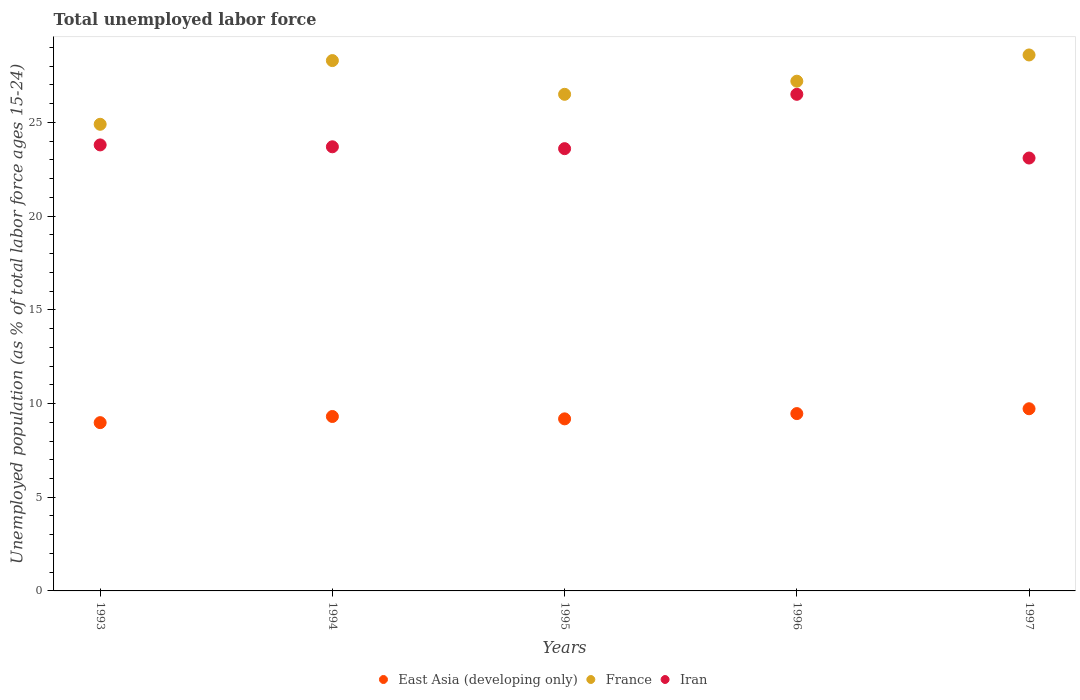How many different coloured dotlines are there?
Your response must be concise. 3. Is the number of dotlines equal to the number of legend labels?
Make the answer very short. Yes. What is the percentage of unemployed population in in East Asia (developing only) in 1996?
Give a very brief answer. 9.46. Across all years, what is the maximum percentage of unemployed population in in France?
Provide a short and direct response. 28.6. Across all years, what is the minimum percentage of unemployed population in in East Asia (developing only)?
Offer a very short reply. 8.98. In which year was the percentage of unemployed population in in France maximum?
Provide a short and direct response. 1997. In which year was the percentage of unemployed population in in Iran minimum?
Give a very brief answer. 1997. What is the total percentage of unemployed population in in East Asia (developing only) in the graph?
Offer a very short reply. 46.65. What is the difference between the percentage of unemployed population in in East Asia (developing only) in 1994 and that in 1996?
Keep it short and to the point. -0.15. What is the difference between the percentage of unemployed population in in France in 1997 and the percentage of unemployed population in in East Asia (developing only) in 1996?
Provide a succinct answer. 19.14. What is the average percentage of unemployed population in in France per year?
Provide a short and direct response. 27.1. In the year 1993, what is the difference between the percentage of unemployed population in in Iran and percentage of unemployed population in in East Asia (developing only)?
Make the answer very short. 14.82. In how many years, is the percentage of unemployed population in in Iran greater than 1 %?
Give a very brief answer. 5. What is the ratio of the percentage of unemployed population in in East Asia (developing only) in 1995 to that in 1996?
Provide a short and direct response. 0.97. Is the percentage of unemployed population in in East Asia (developing only) in 1994 less than that in 1995?
Ensure brevity in your answer.  No. Is the difference between the percentage of unemployed population in in Iran in 1995 and 1997 greater than the difference between the percentage of unemployed population in in East Asia (developing only) in 1995 and 1997?
Give a very brief answer. Yes. What is the difference between the highest and the second highest percentage of unemployed population in in East Asia (developing only)?
Provide a succinct answer. 0.26. What is the difference between the highest and the lowest percentage of unemployed population in in East Asia (developing only)?
Keep it short and to the point. 0.74. In how many years, is the percentage of unemployed population in in East Asia (developing only) greater than the average percentage of unemployed population in in East Asia (developing only) taken over all years?
Make the answer very short. 2. Is the sum of the percentage of unemployed population in in East Asia (developing only) in 1995 and 1996 greater than the maximum percentage of unemployed population in in Iran across all years?
Your answer should be very brief. No. Is it the case that in every year, the sum of the percentage of unemployed population in in East Asia (developing only) and percentage of unemployed population in in France  is greater than the percentage of unemployed population in in Iran?
Your answer should be very brief. Yes. Does the percentage of unemployed population in in Iran monotonically increase over the years?
Your response must be concise. No. Is the percentage of unemployed population in in France strictly greater than the percentage of unemployed population in in Iran over the years?
Your response must be concise. Yes. How many dotlines are there?
Give a very brief answer. 3. How many years are there in the graph?
Keep it short and to the point. 5. Are the values on the major ticks of Y-axis written in scientific E-notation?
Your answer should be compact. No. Where does the legend appear in the graph?
Your answer should be compact. Bottom center. How are the legend labels stacked?
Provide a succinct answer. Horizontal. What is the title of the graph?
Your answer should be compact. Total unemployed labor force. What is the label or title of the X-axis?
Keep it short and to the point. Years. What is the label or title of the Y-axis?
Your answer should be compact. Unemployed population (as % of total labor force ages 15-24). What is the Unemployed population (as % of total labor force ages 15-24) in East Asia (developing only) in 1993?
Ensure brevity in your answer.  8.98. What is the Unemployed population (as % of total labor force ages 15-24) in France in 1993?
Give a very brief answer. 24.9. What is the Unemployed population (as % of total labor force ages 15-24) in Iran in 1993?
Offer a terse response. 23.8. What is the Unemployed population (as % of total labor force ages 15-24) of East Asia (developing only) in 1994?
Provide a succinct answer. 9.31. What is the Unemployed population (as % of total labor force ages 15-24) of France in 1994?
Ensure brevity in your answer.  28.3. What is the Unemployed population (as % of total labor force ages 15-24) in Iran in 1994?
Keep it short and to the point. 23.7. What is the Unemployed population (as % of total labor force ages 15-24) in East Asia (developing only) in 1995?
Your response must be concise. 9.18. What is the Unemployed population (as % of total labor force ages 15-24) in Iran in 1995?
Provide a succinct answer. 23.6. What is the Unemployed population (as % of total labor force ages 15-24) of East Asia (developing only) in 1996?
Provide a succinct answer. 9.46. What is the Unemployed population (as % of total labor force ages 15-24) in France in 1996?
Your answer should be very brief. 27.2. What is the Unemployed population (as % of total labor force ages 15-24) of Iran in 1996?
Make the answer very short. 26.5. What is the Unemployed population (as % of total labor force ages 15-24) in East Asia (developing only) in 1997?
Offer a very short reply. 9.72. What is the Unemployed population (as % of total labor force ages 15-24) of France in 1997?
Offer a terse response. 28.6. What is the Unemployed population (as % of total labor force ages 15-24) of Iran in 1997?
Keep it short and to the point. 23.1. Across all years, what is the maximum Unemployed population (as % of total labor force ages 15-24) in East Asia (developing only)?
Offer a very short reply. 9.72. Across all years, what is the maximum Unemployed population (as % of total labor force ages 15-24) of France?
Keep it short and to the point. 28.6. Across all years, what is the maximum Unemployed population (as % of total labor force ages 15-24) of Iran?
Provide a short and direct response. 26.5. Across all years, what is the minimum Unemployed population (as % of total labor force ages 15-24) in East Asia (developing only)?
Your answer should be compact. 8.98. Across all years, what is the minimum Unemployed population (as % of total labor force ages 15-24) of France?
Offer a very short reply. 24.9. Across all years, what is the minimum Unemployed population (as % of total labor force ages 15-24) of Iran?
Ensure brevity in your answer.  23.1. What is the total Unemployed population (as % of total labor force ages 15-24) of East Asia (developing only) in the graph?
Make the answer very short. 46.65. What is the total Unemployed population (as % of total labor force ages 15-24) in France in the graph?
Provide a succinct answer. 135.5. What is the total Unemployed population (as % of total labor force ages 15-24) in Iran in the graph?
Give a very brief answer. 120.7. What is the difference between the Unemployed population (as % of total labor force ages 15-24) of East Asia (developing only) in 1993 and that in 1994?
Your answer should be very brief. -0.33. What is the difference between the Unemployed population (as % of total labor force ages 15-24) in Iran in 1993 and that in 1994?
Make the answer very short. 0.1. What is the difference between the Unemployed population (as % of total labor force ages 15-24) in East Asia (developing only) in 1993 and that in 1995?
Keep it short and to the point. -0.2. What is the difference between the Unemployed population (as % of total labor force ages 15-24) in France in 1993 and that in 1995?
Offer a terse response. -1.6. What is the difference between the Unemployed population (as % of total labor force ages 15-24) of East Asia (developing only) in 1993 and that in 1996?
Provide a short and direct response. -0.48. What is the difference between the Unemployed population (as % of total labor force ages 15-24) in East Asia (developing only) in 1993 and that in 1997?
Your answer should be compact. -0.74. What is the difference between the Unemployed population (as % of total labor force ages 15-24) of France in 1993 and that in 1997?
Ensure brevity in your answer.  -3.7. What is the difference between the Unemployed population (as % of total labor force ages 15-24) in Iran in 1993 and that in 1997?
Ensure brevity in your answer.  0.7. What is the difference between the Unemployed population (as % of total labor force ages 15-24) in East Asia (developing only) in 1994 and that in 1995?
Ensure brevity in your answer.  0.13. What is the difference between the Unemployed population (as % of total labor force ages 15-24) in France in 1994 and that in 1995?
Your answer should be very brief. 1.8. What is the difference between the Unemployed population (as % of total labor force ages 15-24) of Iran in 1994 and that in 1995?
Keep it short and to the point. 0.1. What is the difference between the Unemployed population (as % of total labor force ages 15-24) in East Asia (developing only) in 1994 and that in 1996?
Your answer should be compact. -0.15. What is the difference between the Unemployed population (as % of total labor force ages 15-24) of France in 1994 and that in 1996?
Keep it short and to the point. 1.1. What is the difference between the Unemployed population (as % of total labor force ages 15-24) in East Asia (developing only) in 1994 and that in 1997?
Offer a terse response. -0.41. What is the difference between the Unemployed population (as % of total labor force ages 15-24) of East Asia (developing only) in 1995 and that in 1996?
Provide a short and direct response. -0.28. What is the difference between the Unemployed population (as % of total labor force ages 15-24) of Iran in 1995 and that in 1996?
Make the answer very short. -2.9. What is the difference between the Unemployed population (as % of total labor force ages 15-24) in East Asia (developing only) in 1995 and that in 1997?
Provide a short and direct response. -0.54. What is the difference between the Unemployed population (as % of total labor force ages 15-24) in France in 1995 and that in 1997?
Provide a succinct answer. -2.1. What is the difference between the Unemployed population (as % of total labor force ages 15-24) in East Asia (developing only) in 1996 and that in 1997?
Keep it short and to the point. -0.26. What is the difference between the Unemployed population (as % of total labor force ages 15-24) of Iran in 1996 and that in 1997?
Provide a short and direct response. 3.4. What is the difference between the Unemployed population (as % of total labor force ages 15-24) of East Asia (developing only) in 1993 and the Unemployed population (as % of total labor force ages 15-24) of France in 1994?
Your answer should be compact. -19.32. What is the difference between the Unemployed population (as % of total labor force ages 15-24) of East Asia (developing only) in 1993 and the Unemployed population (as % of total labor force ages 15-24) of Iran in 1994?
Offer a very short reply. -14.72. What is the difference between the Unemployed population (as % of total labor force ages 15-24) in France in 1993 and the Unemployed population (as % of total labor force ages 15-24) in Iran in 1994?
Ensure brevity in your answer.  1.2. What is the difference between the Unemployed population (as % of total labor force ages 15-24) in East Asia (developing only) in 1993 and the Unemployed population (as % of total labor force ages 15-24) in France in 1995?
Offer a very short reply. -17.52. What is the difference between the Unemployed population (as % of total labor force ages 15-24) in East Asia (developing only) in 1993 and the Unemployed population (as % of total labor force ages 15-24) in Iran in 1995?
Your response must be concise. -14.62. What is the difference between the Unemployed population (as % of total labor force ages 15-24) of France in 1993 and the Unemployed population (as % of total labor force ages 15-24) of Iran in 1995?
Provide a succinct answer. 1.3. What is the difference between the Unemployed population (as % of total labor force ages 15-24) in East Asia (developing only) in 1993 and the Unemployed population (as % of total labor force ages 15-24) in France in 1996?
Make the answer very short. -18.22. What is the difference between the Unemployed population (as % of total labor force ages 15-24) in East Asia (developing only) in 1993 and the Unemployed population (as % of total labor force ages 15-24) in Iran in 1996?
Keep it short and to the point. -17.52. What is the difference between the Unemployed population (as % of total labor force ages 15-24) in East Asia (developing only) in 1993 and the Unemployed population (as % of total labor force ages 15-24) in France in 1997?
Keep it short and to the point. -19.62. What is the difference between the Unemployed population (as % of total labor force ages 15-24) in East Asia (developing only) in 1993 and the Unemployed population (as % of total labor force ages 15-24) in Iran in 1997?
Give a very brief answer. -14.12. What is the difference between the Unemployed population (as % of total labor force ages 15-24) in France in 1993 and the Unemployed population (as % of total labor force ages 15-24) in Iran in 1997?
Your answer should be very brief. 1.8. What is the difference between the Unemployed population (as % of total labor force ages 15-24) of East Asia (developing only) in 1994 and the Unemployed population (as % of total labor force ages 15-24) of France in 1995?
Your response must be concise. -17.19. What is the difference between the Unemployed population (as % of total labor force ages 15-24) of East Asia (developing only) in 1994 and the Unemployed population (as % of total labor force ages 15-24) of Iran in 1995?
Ensure brevity in your answer.  -14.29. What is the difference between the Unemployed population (as % of total labor force ages 15-24) in East Asia (developing only) in 1994 and the Unemployed population (as % of total labor force ages 15-24) in France in 1996?
Keep it short and to the point. -17.89. What is the difference between the Unemployed population (as % of total labor force ages 15-24) of East Asia (developing only) in 1994 and the Unemployed population (as % of total labor force ages 15-24) of Iran in 1996?
Provide a succinct answer. -17.19. What is the difference between the Unemployed population (as % of total labor force ages 15-24) of France in 1994 and the Unemployed population (as % of total labor force ages 15-24) of Iran in 1996?
Your response must be concise. 1.8. What is the difference between the Unemployed population (as % of total labor force ages 15-24) in East Asia (developing only) in 1994 and the Unemployed population (as % of total labor force ages 15-24) in France in 1997?
Your response must be concise. -19.29. What is the difference between the Unemployed population (as % of total labor force ages 15-24) in East Asia (developing only) in 1994 and the Unemployed population (as % of total labor force ages 15-24) in Iran in 1997?
Your answer should be very brief. -13.79. What is the difference between the Unemployed population (as % of total labor force ages 15-24) in East Asia (developing only) in 1995 and the Unemployed population (as % of total labor force ages 15-24) in France in 1996?
Your response must be concise. -18.02. What is the difference between the Unemployed population (as % of total labor force ages 15-24) of East Asia (developing only) in 1995 and the Unemployed population (as % of total labor force ages 15-24) of Iran in 1996?
Provide a short and direct response. -17.32. What is the difference between the Unemployed population (as % of total labor force ages 15-24) of East Asia (developing only) in 1995 and the Unemployed population (as % of total labor force ages 15-24) of France in 1997?
Ensure brevity in your answer.  -19.42. What is the difference between the Unemployed population (as % of total labor force ages 15-24) in East Asia (developing only) in 1995 and the Unemployed population (as % of total labor force ages 15-24) in Iran in 1997?
Your answer should be very brief. -13.92. What is the difference between the Unemployed population (as % of total labor force ages 15-24) in France in 1995 and the Unemployed population (as % of total labor force ages 15-24) in Iran in 1997?
Your answer should be compact. 3.4. What is the difference between the Unemployed population (as % of total labor force ages 15-24) of East Asia (developing only) in 1996 and the Unemployed population (as % of total labor force ages 15-24) of France in 1997?
Provide a succinct answer. -19.14. What is the difference between the Unemployed population (as % of total labor force ages 15-24) of East Asia (developing only) in 1996 and the Unemployed population (as % of total labor force ages 15-24) of Iran in 1997?
Offer a very short reply. -13.64. What is the average Unemployed population (as % of total labor force ages 15-24) in East Asia (developing only) per year?
Your response must be concise. 9.33. What is the average Unemployed population (as % of total labor force ages 15-24) in France per year?
Your answer should be very brief. 27.1. What is the average Unemployed population (as % of total labor force ages 15-24) in Iran per year?
Your response must be concise. 24.14. In the year 1993, what is the difference between the Unemployed population (as % of total labor force ages 15-24) of East Asia (developing only) and Unemployed population (as % of total labor force ages 15-24) of France?
Provide a short and direct response. -15.92. In the year 1993, what is the difference between the Unemployed population (as % of total labor force ages 15-24) of East Asia (developing only) and Unemployed population (as % of total labor force ages 15-24) of Iran?
Your answer should be compact. -14.82. In the year 1993, what is the difference between the Unemployed population (as % of total labor force ages 15-24) in France and Unemployed population (as % of total labor force ages 15-24) in Iran?
Offer a terse response. 1.1. In the year 1994, what is the difference between the Unemployed population (as % of total labor force ages 15-24) of East Asia (developing only) and Unemployed population (as % of total labor force ages 15-24) of France?
Provide a succinct answer. -18.99. In the year 1994, what is the difference between the Unemployed population (as % of total labor force ages 15-24) in East Asia (developing only) and Unemployed population (as % of total labor force ages 15-24) in Iran?
Give a very brief answer. -14.39. In the year 1995, what is the difference between the Unemployed population (as % of total labor force ages 15-24) of East Asia (developing only) and Unemployed population (as % of total labor force ages 15-24) of France?
Give a very brief answer. -17.32. In the year 1995, what is the difference between the Unemployed population (as % of total labor force ages 15-24) in East Asia (developing only) and Unemployed population (as % of total labor force ages 15-24) in Iran?
Provide a succinct answer. -14.42. In the year 1995, what is the difference between the Unemployed population (as % of total labor force ages 15-24) in France and Unemployed population (as % of total labor force ages 15-24) in Iran?
Ensure brevity in your answer.  2.9. In the year 1996, what is the difference between the Unemployed population (as % of total labor force ages 15-24) in East Asia (developing only) and Unemployed population (as % of total labor force ages 15-24) in France?
Make the answer very short. -17.74. In the year 1996, what is the difference between the Unemployed population (as % of total labor force ages 15-24) of East Asia (developing only) and Unemployed population (as % of total labor force ages 15-24) of Iran?
Your answer should be compact. -17.04. In the year 1997, what is the difference between the Unemployed population (as % of total labor force ages 15-24) of East Asia (developing only) and Unemployed population (as % of total labor force ages 15-24) of France?
Offer a terse response. -18.88. In the year 1997, what is the difference between the Unemployed population (as % of total labor force ages 15-24) in East Asia (developing only) and Unemployed population (as % of total labor force ages 15-24) in Iran?
Offer a terse response. -13.38. In the year 1997, what is the difference between the Unemployed population (as % of total labor force ages 15-24) of France and Unemployed population (as % of total labor force ages 15-24) of Iran?
Make the answer very short. 5.5. What is the ratio of the Unemployed population (as % of total labor force ages 15-24) in East Asia (developing only) in 1993 to that in 1994?
Offer a very short reply. 0.96. What is the ratio of the Unemployed population (as % of total labor force ages 15-24) of France in 1993 to that in 1994?
Provide a succinct answer. 0.88. What is the ratio of the Unemployed population (as % of total labor force ages 15-24) in East Asia (developing only) in 1993 to that in 1995?
Give a very brief answer. 0.98. What is the ratio of the Unemployed population (as % of total labor force ages 15-24) of France in 1993 to that in 1995?
Offer a very short reply. 0.94. What is the ratio of the Unemployed population (as % of total labor force ages 15-24) in Iran in 1993 to that in 1995?
Offer a terse response. 1.01. What is the ratio of the Unemployed population (as % of total labor force ages 15-24) of East Asia (developing only) in 1993 to that in 1996?
Provide a short and direct response. 0.95. What is the ratio of the Unemployed population (as % of total labor force ages 15-24) of France in 1993 to that in 1996?
Ensure brevity in your answer.  0.92. What is the ratio of the Unemployed population (as % of total labor force ages 15-24) in Iran in 1993 to that in 1996?
Your response must be concise. 0.9. What is the ratio of the Unemployed population (as % of total labor force ages 15-24) of East Asia (developing only) in 1993 to that in 1997?
Provide a succinct answer. 0.92. What is the ratio of the Unemployed population (as % of total labor force ages 15-24) in France in 1993 to that in 1997?
Make the answer very short. 0.87. What is the ratio of the Unemployed population (as % of total labor force ages 15-24) in Iran in 1993 to that in 1997?
Offer a very short reply. 1.03. What is the ratio of the Unemployed population (as % of total labor force ages 15-24) in East Asia (developing only) in 1994 to that in 1995?
Offer a terse response. 1.01. What is the ratio of the Unemployed population (as % of total labor force ages 15-24) in France in 1994 to that in 1995?
Your answer should be very brief. 1.07. What is the ratio of the Unemployed population (as % of total labor force ages 15-24) of Iran in 1994 to that in 1995?
Your answer should be very brief. 1. What is the ratio of the Unemployed population (as % of total labor force ages 15-24) in East Asia (developing only) in 1994 to that in 1996?
Keep it short and to the point. 0.98. What is the ratio of the Unemployed population (as % of total labor force ages 15-24) of France in 1994 to that in 1996?
Your answer should be compact. 1.04. What is the ratio of the Unemployed population (as % of total labor force ages 15-24) of Iran in 1994 to that in 1996?
Your answer should be compact. 0.89. What is the ratio of the Unemployed population (as % of total labor force ages 15-24) in East Asia (developing only) in 1994 to that in 1997?
Offer a very short reply. 0.96. What is the ratio of the Unemployed population (as % of total labor force ages 15-24) of France in 1994 to that in 1997?
Your response must be concise. 0.99. What is the ratio of the Unemployed population (as % of total labor force ages 15-24) in East Asia (developing only) in 1995 to that in 1996?
Offer a terse response. 0.97. What is the ratio of the Unemployed population (as % of total labor force ages 15-24) in France in 1995 to that in 1996?
Your answer should be compact. 0.97. What is the ratio of the Unemployed population (as % of total labor force ages 15-24) of Iran in 1995 to that in 1996?
Your response must be concise. 0.89. What is the ratio of the Unemployed population (as % of total labor force ages 15-24) in East Asia (developing only) in 1995 to that in 1997?
Ensure brevity in your answer.  0.94. What is the ratio of the Unemployed population (as % of total labor force ages 15-24) in France in 1995 to that in 1997?
Give a very brief answer. 0.93. What is the ratio of the Unemployed population (as % of total labor force ages 15-24) in Iran in 1995 to that in 1997?
Offer a terse response. 1.02. What is the ratio of the Unemployed population (as % of total labor force ages 15-24) in East Asia (developing only) in 1996 to that in 1997?
Offer a terse response. 0.97. What is the ratio of the Unemployed population (as % of total labor force ages 15-24) in France in 1996 to that in 1997?
Offer a very short reply. 0.95. What is the ratio of the Unemployed population (as % of total labor force ages 15-24) in Iran in 1996 to that in 1997?
Provide a short and direct response. 1.15. What is the difference between the highest and the second highest Unemployed population (as % of total labor force ages 15-24) in East Asia (developing only)?
Keep it short and to the point. 0.26. What is the difference between the highest and the second highest Unemployed population (as % of total labor force ages 15-24) in France?
Your response must be concise. 0.3. What is the difference between the highest and the lowest Unemployed population (as % of total labor force ages 15-24) of East Asia (developing only)?
Ensure brevity in your answer.  0.74. What is the difference between the highest and the lowest Unemployed population (as % of total labor force ages 15-24) in France?
Offer a terse response. 3.7. 